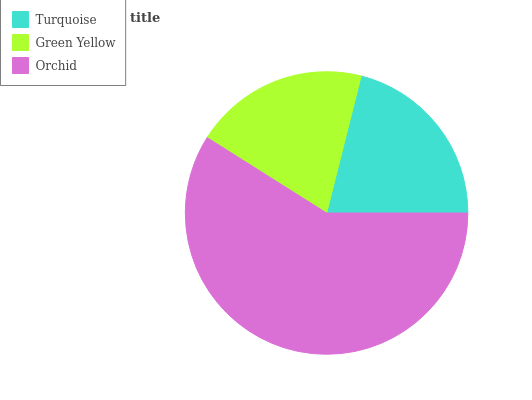Is Green Yellow the minimum?
Answer yes or no. Yes. Is Orchid the maximum?
Answer yes or no. Yes. Is Orchid the minimum?
Answer yes or no. No. Is Green Yellow the maximum?
Answer yes or no. No. Is Orchid greater than Green Yellow?
Answer yes or no. Yes. Is Green Yellow less than Orchid?
Answer yes or no. Yes. Is Green Yellow greater than Orchid?
Answer yes or no. No. Is Orchid less than Green Yellow?
Answer yes or no. No. Is Turquoise the high median?
Answer yes or no. Yes. Is Turquoise the low median?
Answer yes or no. Yes. Is Orchid the high median?
Answer yes or no. No. Is Green Yellow the low median?
Answer yes or no. No. 